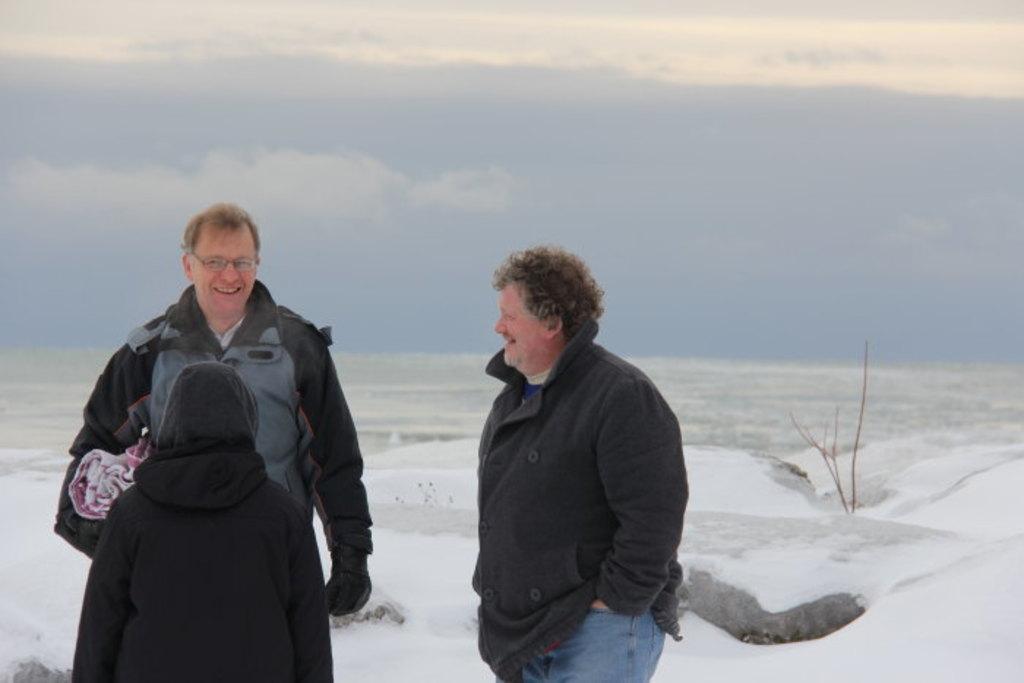Please provide a concise description of this image. In this image we can see a group of persons are standing, and smiling, he is wearing the jacket, here is the ice, at above here is the sky. 